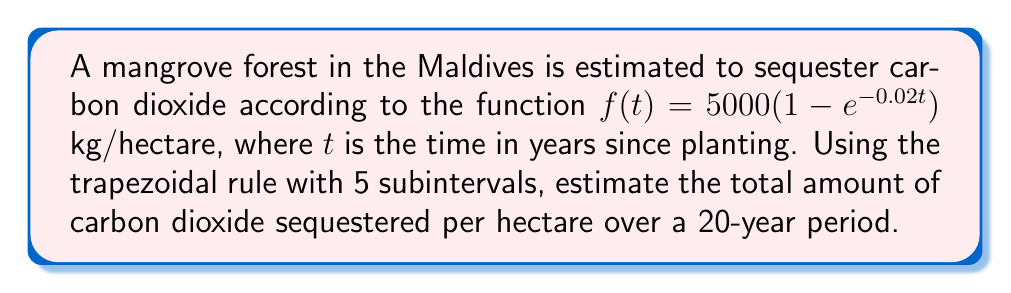What is the answer to this math problem? To solve this problem, we'll use the trapezoidal rule for numerical integration:

1) The trapezoidal rule is given by:
   $$\int_{a}^{b} f(x) dx \approx \frac{h}{2}[f(x_0) + 2f(x_1) + 2f(x_2) + ... + 2f(x_{n-1}) + f(x_n)]$$
   where $h = \frac{b-a}{n}$, and $n$ is the number of subintervals.

2) In our case:
   $a = 0$, $b = 20$, $n = 5$
   $h = \frac{20-0}{5} = 4$

3) We need to evaluate $f(t)$ at $t = 0, 4, 8, 12, 16, 20$:
   
   $f(0) = 5000(1 - e^{-0.02 \cdot 0}) = 0$
   $f(4) = 5000(1 - e^{-0.02 \cdot 4}) = 3921.95$
   $f(8) = 5000(1 - e^{-0.02 \cdot 8}) = 6321.21$
   $f(12) = 5000(1 - e^{-0.02 \cdot 12}) = 7814.02$
   $f(16) = 5000(1 - e^{-0.02 \cdot 16}) = 8743.43$
   $f(20) = 5000(1 - e^{-0.02 \cdot 20}) = 9321.05$

4) Applying the trapezoidal rule:

   $$\int_{0}^{20} f(t) dt \approx \frac{4}{2}[0 + 2(3921.95) + 2(6321.21) + 2(7814.02) + 2(8743.43) + 9321.05]$$

5) Simplifying:
   $$\approx 2[0 + 7843.90 + 12642.42 + 15628.04 + 17486.86 + 9321.05]$$
   $$\approx 2[62922.27] = 125844.54$$

Therefore, the estimated total amount of carbon dioxide sequestered per hectare over a 20-year period is approximately 125,844.54 kg.
Answer: 125,844.54 kg/hectare 